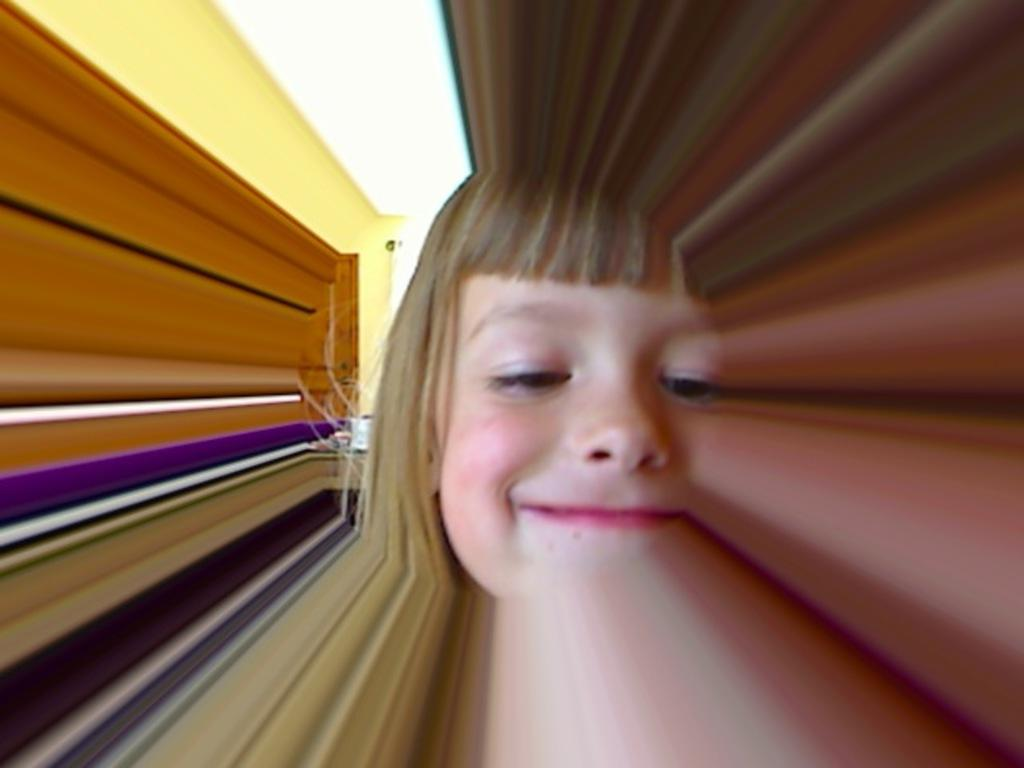Who is present in the image? There is a girl in the image. What is the girl's expression? The girl is smiling. What can be seen in the background of the image? There is a wall, a door, and other objects in the background of the image. What type of support can be seen in the image? There is no specific support mentioned or visible in the image. What nation is represented by the girl in the image? The image does not indicate any specific nation or nationality associated with the girl. 